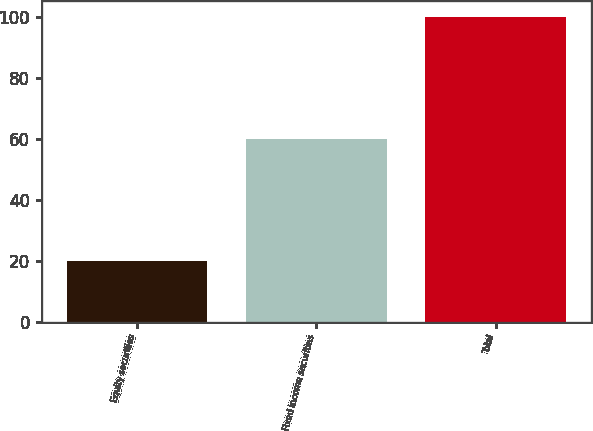Convert chart. <chart><loc_0><loc_0><loc_500><loc_500><bar_chart><fcel>Equity securities<fcel>Fixed income securities<fcel>Total<nl><fcel>20<fcel>60<fcel>100<nl></chart> 